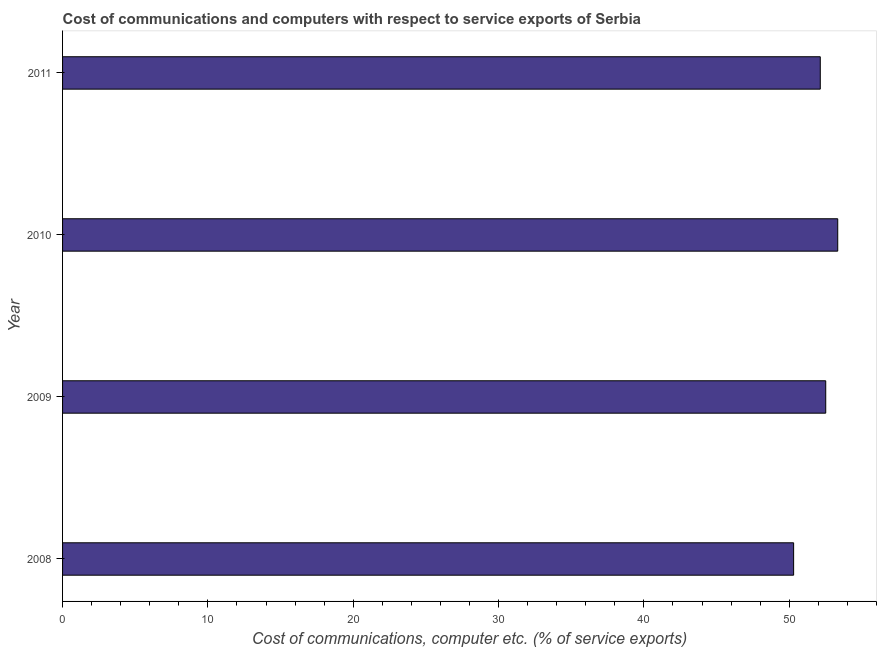What is the title of the graph?
Provide a short and direct response. Cost of communications and computers with respect to service exports of Serbia. What is the label or title of the X-axis?
Your response must be concise. Cost of communications, computer etc. (% of service exports). What is the label or title of the Y-axis?
Your answer should be compact. Year. What is the cost of communications and computer in 2009?
Ensure brevity in your answer.  52.51. Across all years, what is the maximum cost of communications and computer?
Provide a succinct answer. 53.34. Across all years, what is the minimum cost of communications and computer?
Offer a terse response. 50.3. In which year was the cost of communications and computer maximum?
Make the answer very short. 2010. What is the sum of the cost of communications and computer?
Your answer should be compact. 208.29. What is the difference between the cost of communications and computer in 2008 and 2009?
Your answer should be very brief. -2.21. What is the average cost of communications and computer per year?
Give a very brief answer. 52.07. What is the median cost of communications and computer?
Offer a very short reply. 52.32. Do a majority of the years between 2011 and 2010 (inclusive) have cost of communications and computer greater than 24 %?
Keep it short and to the point. No. Is the cost of communications and computer in 2008 less than that in 2010?
Provide a succinct answer. Yes. What is the difference between the highest and the second highest cost of communications and computer?
Offer a very short reply. 0.83. What is the difference between the highest and the lowest cost of communications and computer?
Your answer should be very brief. 3.03. How many bars are there?
Ensure brevity in your answer.  4. What is the difference between two consecutive major ticks on the X-axis?
Your answer should be very brief. 10. Are the values on the major ticks of X-axis written in scientific E-notation?
Your response must be concise. No. What is the Cost of communications, computer etc. (% of service exports) in 2008?
Your answer should be compact. 50.3. What is the Cost of communications, computer etc. (% of service exports) in 2009?
Offer a very short reply. 52.51. What is the Cost of communications, computer etc. (% of service exports) of 2010?
Give a very brief answer. 53.34. What is the Cost of communications, computer etc. (% of service exports) of 2011?
Your answer should be compact. 52.14. What is the difference between the Cost of communications, computer etc. (% of service exports) in 2008 and 2009?
Ensure brevity in your answer.  -2.21. What is the difference between the Cost of communications, computer etc. (% of service exports) in 2008 and 2010?
Your answer should be very brief. -3.03. What is the difference between the Cost of communications, computer etc. (% of service exports) in 2008 and 2011?
Offer a very short reply. -1.83. What is the difference between the Cost of communications, computer etc. (% of service exports) in 2009 and 2010?
Your answer should be very brief. -0.83. What is the difference between the Cost of communications, computer etc. (% of service exports) in 2009 and 2011?
Ensure brevity in your answer.  0.38. What is the difference between the Cost of communications, computer etc. (% of service exports) in 2010 and 2011?
Offer a very short reply. 1.2. What is the ratio of the Cost of communications, computer etc. (% of service exports) in 2008 to that in 2009?
Your answer should be very brief. 0.96. What is the ratio of the Cost of communications, computer etc. (% of service exports) in 2008 to that in 2010?
Provide a succinct answer. 0.94. 